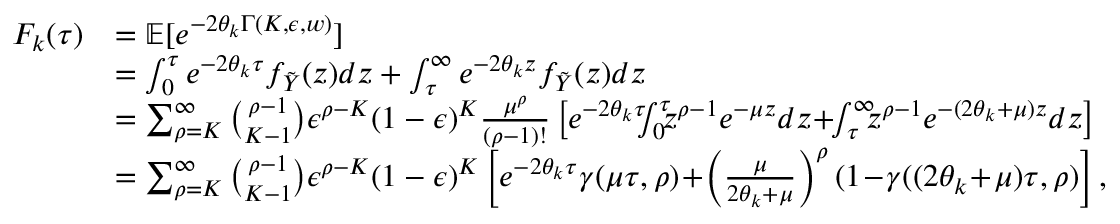<formula> <loc_0><loc_0><loc_500><loc_500>\begin{array} { r l } { F _ { k } ( \tau ) } & { = { \mathbb { E } } [ e ^ { - 2 \theta _ { k } \Gamma ( K , \epsilon , w ) } ] } \\ & { = \int _ { 0 } ^ { \tau } e ^ { - 2 \theta _ { k } \tau } f _ { \tilde { Y } } ( z ) d z + \int _ { \tau } ^ { \infty } e ^ { - 2 \theta _ { k } z } f _ { \tilde { Y } } ( z ) d z } \\ & { = \sum _ { \rho = K } ^ { \infty } \binom { \rho - 1 } { K - 1 } \epsilon ^ { \rho - K } ( 1 - \epsilon ) ^ { K } \frac { \mu ^ { \rho } } { ( \rho - 1 ) ! } \left [ e ^ { - 2 \theta _ { k } \tau } \, \int _ { 0 } ^ { \tau } \, z ^ { \rho - 1 } e ^ { - \mu z } d z \, + \, \int _ { \tau } ^ { \infty } \, z ^ { \rho - 1 } e ^ { - ( 2 \theta _ { k } + \mu ) z } d z \right ] } \\ & { = \sum _ { \rho = K } ^ { \infty } \binom { \rho - 1 } { K - 1 } \epsilon ^ { \rho - K } ( 1 - \epsilon ) ^ { K } \left [ e ^ { - 2 \theta _ { k } \tau } \gamma ( \mu \tau , \rho ) \, + \, \left ( \frac { \mu } { 2 \theta _ { k } + \mu } \right ) ^ { \rho } ( 1 \, - \, \gamma ( ( 2 \theta _ { k } \, + \, \mu ) \tau , \rho ) \right ] , } \end{array}</formula> 